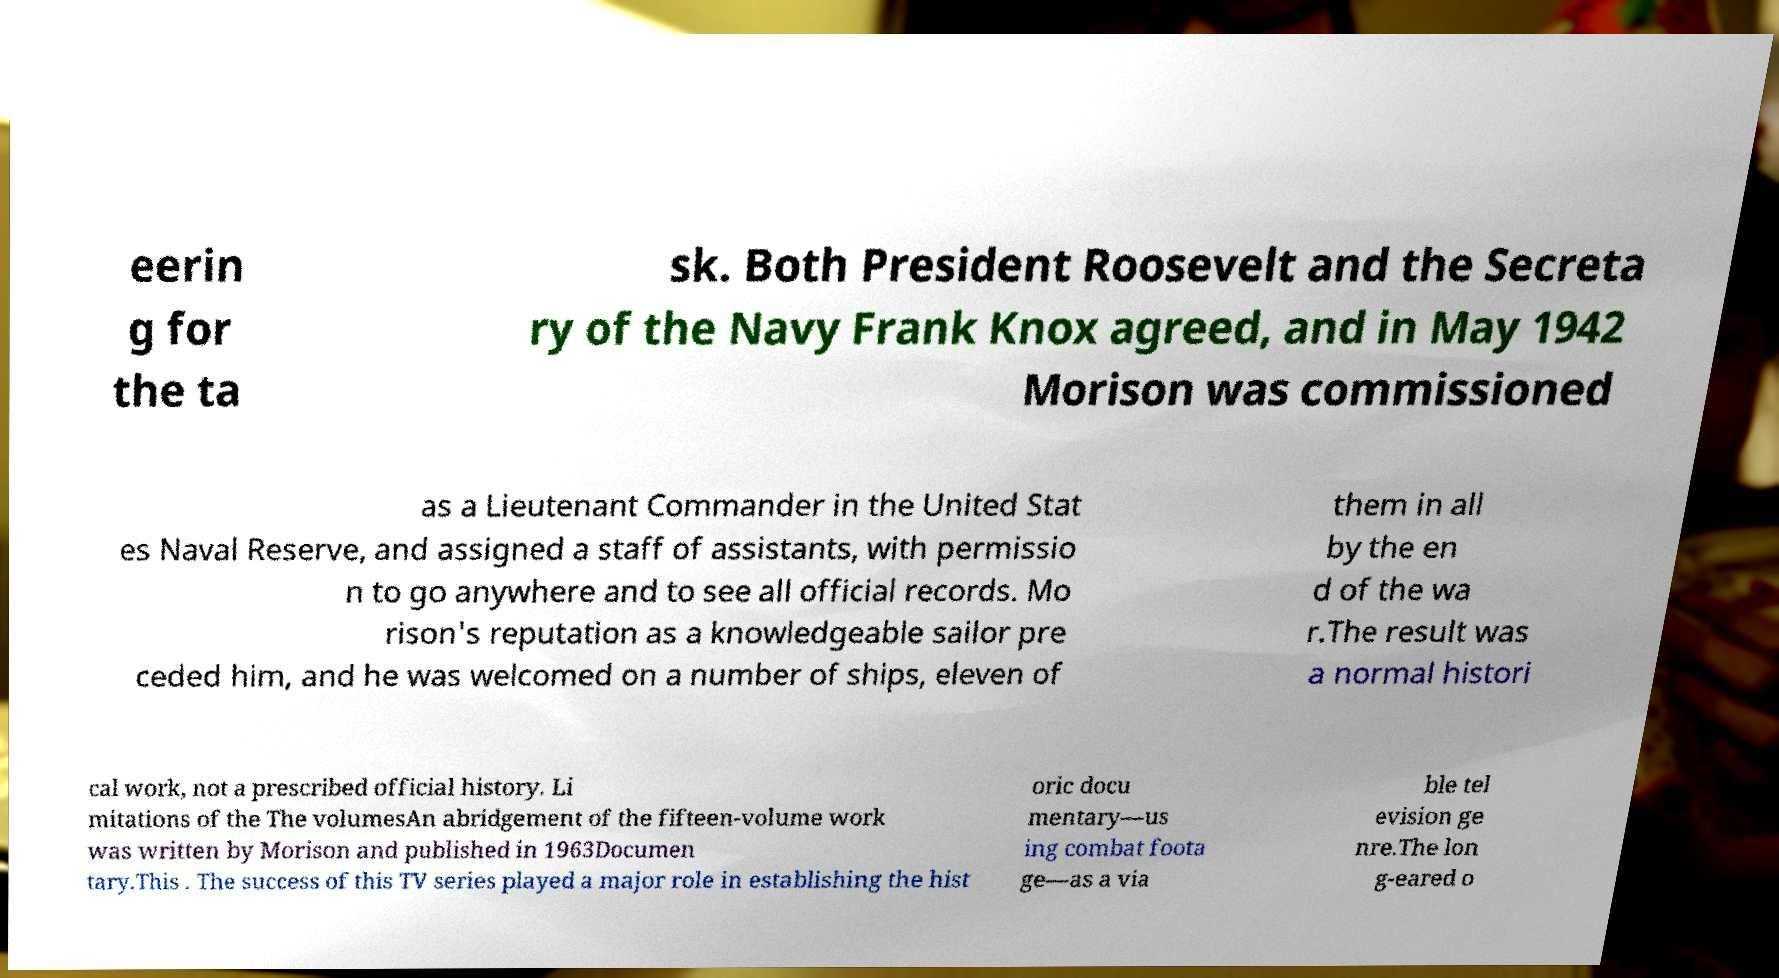There's text embedded in this image that I need extracted. Can you transcribe it verbatim? eerin g for the ta sk. Both President Roosevelt and the Secreta ry of the Navy Frank Knox agreed, and in May 1942 Morison was commissioned as a Lieutenant Commander in the United Stat es Naval Reserve, and assigned a staff of assistants, with permissio n to go anywhere and to see all official records. Mo rison's reputation as a knowledgeable sailor pre ceded him, and he was welcomed on a number of ships, eleven of them in all by the en d of the wa r.The result was a normal histori cal work, not a prescribed official history. Li mitations of the The volumesAn abridgement of the fifteen-volume work was written by Morison and published in 1963Documen tary.This . The success of this TV series played a major role in establishing the hist oric docu mentary—us ing combat foota ge—as a via ble tel evision ge nre.The lon g-eared o 